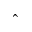<formula> <loc_0><loc_0><loc_500><loc_500>\hat { \ }</formula> 